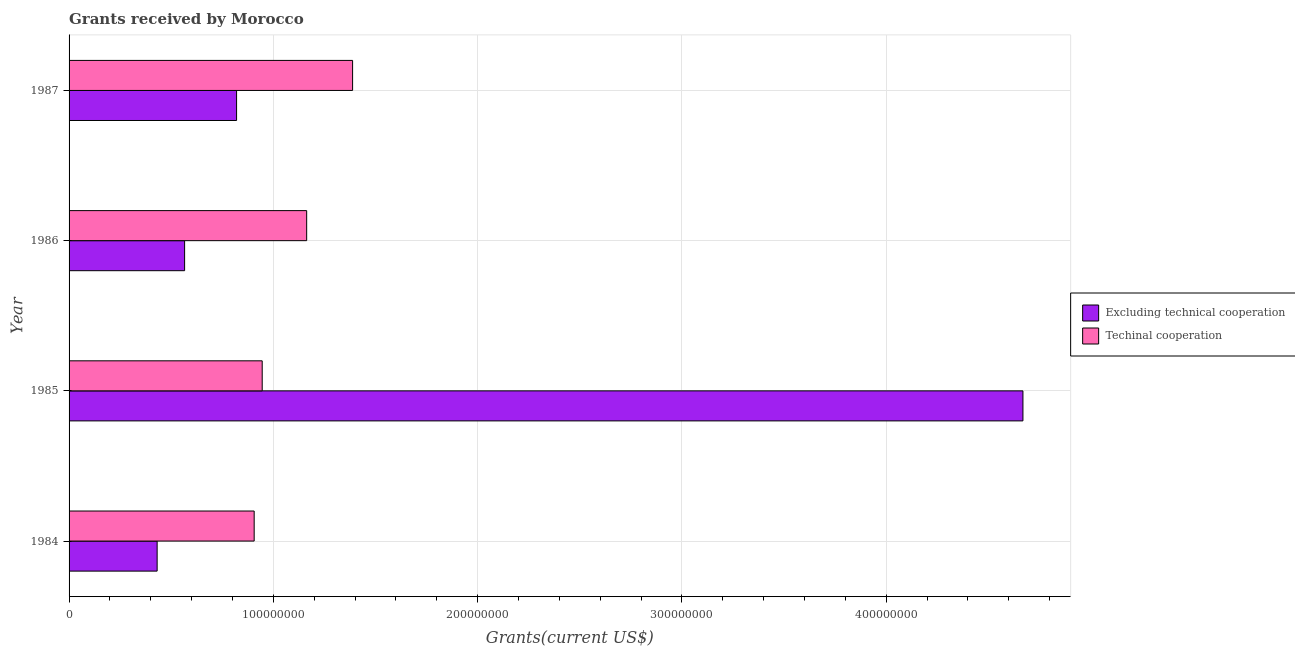Are the number of bars per tick equal to the number of legend labels?
Your answer should be very brief. Yes. How many bars are there on the 2nd tick from the bottom?
Your response must be concise. 2. What is the amount of grants received(excluding technical cooperation) in 1987?
Your response must be concise. 8.20e+07. Across all years, what is the maximum amount of grants received(excluding technical cooperation)?
Keep it short and to the point. 4.67e+08. Across all years, what is the minimum amount of grants received(excluding technical cooperation)?
Provide a short and direct response. 4.31e+07. In which year was the amount of grants received(excluding technical cooperation) maximum?
Keep it short and to the point. 1985. In which year was the amount of grants received(excluding technical cooperation) minimum?
Your answer should be very brief. 1984. What is the total amount of grants received(including technical cooperation) in the graph?
Give a very brief answer. 4.40e+08. What is the difference between the amount of grants received(excluding technical cooperation) in 1986 and that in 1987?
Offer a very short reply. -2.54e+07. What is the difference between the amount of grants received(including technical cooperation) in 1987 and the amount of grants received(excluding technical cooperation) in 1984?
Offer a terse response. 9.57e+07. What is the average amount of grants received(excluding technical cooperation) per year?
Your response must be concise. 1.62e+08. In the year 1985, what is the difference between the amount of grants received(excluding technical cooperation) and amount of grants received(including technical cooperation)?
Provide a succinct answer. 3.72e+08. What is the ratio of the amount of grants received(excluding technical cooperation) in 1985 to that in 1986?
Offer a very short reply. 8.26. Is the difference between the amount of grants received(excluding technical cooperation) in 1985 and 1987 greater than the difference between the amount of grants received(including technical cooperation) in 1985 and 1987?
Your answer should be very brief. Yes. What is the difference between the highest and the second highest amount of grants received(excluding technical cooperation)?
Keep it short and to the point. 3.85e+08. What is the difference between the highest and the lowest amount of grants received(excluding technical cooperation)?
Your answer should be compact. 4.24e+08. In how many years, is the amount of grants received(excluding technical cooperation) greater than the average amount of grants received(excluding technical cooperation) taken over all years?
Offer a terse response. 1. Is the sum of the amount of grants received(excluding technical cooperation) in 1985 and 1986 greater than the maximum amount of grants received(including technical cooperation) across all years?
Provide a short and direct response. Yes. What does the 1st bar from the top in 1984 represents?
Keep it short and to the point. Techinal cooperation. What does the 2nd bar from the bottom in 1986 represents?
Provide a short and direct response. Techinal cooperation. What is the difference between two consecutive major ticks on the X-axis?
Offer a very short reply. 1.00e+08. Are the values on the major ticks of X-axis written in scientific E-notation?
Make the answer very short. No. Does the graph contain any zero values?
Make the answer very short. No. Where does the legend appear in the graph?
Offer a very short reply. Center right. How are the legend labels stacked?
Make the answer very short. Vertical. What is the title of the graph?
Offer a very short reply. Grants received by Morocco. What is the label or title of the X-axis?
Provide a short and direct response. Grants(current US$). What is the Grants(current US$) of Excluding technical cooperation in 1984?
Your response must be concise. 4.31e+07. What is the Grants(current US$) in Techinal cooperation in 1984?
Your answer should be compact. 9.06e+07. What is the Grants(current US$) in Excluding technical cooperation in 1985?
Your answer should be compact. 4.67e+08. What is the Grants(current US$) of Techinal cooperation in 1985?
Provide a succinct answer. 9.45e+07. What is the Grants(current US$) of Excluding technical cooperation in 1986?
Your answer should be compact. 5.66e+07. What is the Grants(current US$) in Techinal cooperation in 1986?
Offer a very short reply. 1.16e+08. What is the Grants(current US$) of Excluding technical cooperation in 1987?
Provide a short and direct response. 8.20e+07. What is the Grants(current US$) of Techinal cooperation in 1987?
Keep it short and to the point. 1.39e+08. Across all years, what is the maximum Grants(current US$) in Excluding technical cooperation?
Provide a succinct answer. 4.67e+08. Across all years, what is the maximum Grants(current US$) of Techinal cooperation?
Provide a succinct answer. 1.39e+08. Across all years, what is the minimum Grants(current US$) of Excluding technical cooperation?
Offer a very short reply. 4.31e+07. Across all years, what is the minimum Grants(current US$) in Techinal cooperation?
Provide a succinct answer. 9.06e+07. What is the total Grants(current US$) of Excluding technical cooperation in the graph?
Your response must be concise. 6.49e+08. What is the total Grants(current US$) of Techinal cooperation in the graph?
Make the answer very short. 4.40e+08. What is the difference between the Grants(current US$) of Excluding technical cooperation in 1984 and that in 1985?
Keep it short and to the point. -4.24e+08. What is the difference between the Grants(current US$) in Techinal cooperation in 1984 and that in 1985?
Provide a short and direct response. -3.93e+06. What is the difference between the Grants(current US$) of Excluding technical cooperation in 1984 and that in 1986?
Ensure brevity in your answer.  -1.34e+07. What is the difference between the Grants(current US$) of Techinal cooperation in 1984 and that in 1986?
Your response must be concise. -2.57e+07. What is the difference between the Grants(current US$) of Excluding technical cooperation in 1984 and that in 1987?
Make the answer very short. -3.89e+07. What is the difference between the Grants(current US$) in Techinal cooperation in 1984 and that in 1987?
Your answer should be very brief. -4.82e+07. What is the difference between the Grants(current US$) of Excluding technical cooperation in 1985 and that in 1986?
Offer a very short reply. 4.10e+08. What is the difference between the Grants(current US$) in Techinal cooperation in 1985 and that in 1986?
Your answer should be compact. -2.18e+07. What is the difference between the Grants(current US$) in Excluding technical cooperation in 1985 and that in 1987?
Ensure brevity in your answer.  3.85e+08. What is the difference between the Grants(current US$) in Techinal cooperation in 1985 and that in 1987?
Your response must be concise. -4.42e+07. What is the difference between the Grants(current US$) of Excluding technical cooperation in 1986 and that in 1987?
Give a very brief answer. -2.54e+07. What is the difference between the Grants(current US$) in Techinal cooperation in 1986 and that in 1987?
Offer a very short reply. -2.25e+07. What is the difference between the Grants(current US$) in Excluding technical cooperation in 1984 and the Grants(current US$) in Techinal cooperation in 1985?
Your answer should be very brief. -5.14e+07. What is the difference between the Grants(current US$) in Excluding technical cooperation in 1984 and the Grants(current US$) in Techinal cooperation in 1986?
Provide a short and direct response. -7.32e+07. What is the difference between the Grants(current US$) in Excluding technical cooperation in 1984 and the Grants(current US$) in Techinal cooperation in 1987?
Make the answer very short. -9.57e+07. What is the difference between the Grants(current US$) of Excluding technical cooperation in 1985 and the Grants(current US$) of Techinal cooperation in 1986?
Provide a succinct answer. 3.51e+08. What is the difference between the Grants(current US$) in Excluding technical cooperation in 1985 and the Grants(current US$) in Techinal cooperation in 1987?
Keep it short and to the point. 3.28e+08. What is the difference between the Grants(current US$) in Excluding technical cooperation in 1986 and the Grants(current US$) in Techinal cooperation in 1987?
Provide a short and direct response. -8.22e+07. What is the average Grants(current US$) in Excluding technical cooperation per year?
Provide a succinct answer. 1.62e+08. What is the average Grants(current US$) in Techinal cooperation per year?
Give a very brief answer. 1.10e+08. In the year 1984, what is the difference between the Grants(current US$) in Excluding technical cooperation and Grants(current US$) in Techinal cooperation?
Make the answer very short. -4.75e+07. In the year 1985, what is the difference between the Grants(current US$) in Excluding technical cooperation and Grants(current US$) in Techinal cooperation?
Ensure brevity in your answer.  3.72e+08. In the year 1986, what is the difference between the Grants(current US$) in Excluding technical cooperation and Grants(current US$) in Techinal cooperation?
Provide a short and direct response. -5.98e+07. In the year 1987, what is the difference between the Grants(current US$) of Excluding technical cooperation and Grants(current US$) of Techinal cooperation?
Your response must be concise. -5.68e+07. What is the ratio of the Grants(current US$) of Excluding technical cooperation in 1984 to that in 1985?
Offer a terse response. 0.09. What is the ratio of the Grants(current US$) in Techinal cooperation in 1984 to that in 1985?
Give a very brief answer. 0.96. What is the ratio of the Grants(current US$) in Excluding technical cooperation in 1984 to that in 1986?
Your response must be concise. 0.76. What is the ratio of the Grants(current US$) of Techinal cooperation in 1984 to that in 1986?
Ensure brevity in your answer.  0.78. What is the ratio of the Grants(current US$) in Excluding technical cooperation in 1984 to that in 1987?
Your response must be concise. 0.53. What is the ratio of the Grants(current US$) of Techinal cooperation in 1984 to that in 1987?
Make the answer very short. 0.65. What is the ratio of the Grants(current US$) in Excluding technical cooperation in 1985 to that in 1986?
Ensure brevity in your answer.  8.26. What is the ratio of the Grants(current US$) of Techinal cooperation in 1985 to that in 1986?
Provide a short and direct response. 0.81. What is the ratio of the Grants(current US$) in Excluding technical cooperation in 1985 to that in 1987?
Provide a succinct answer. 5.69. What is the ratio of the Grants(current US$) in Techinal cooperation in 1985 to that in 1987?
Keep it short and to the point. 0.68. What is the ratio of the Grants(current US$) in Excluding technical cooperation in 1986 to that in 1987?
Make the answer very short. 0.69. What is the ratio of the Grants(current US$) in Techinal cooperation in 1986 to that in 1987?
Offer a very short reply. 0.84. What is the difference between the highest and the second highest Grants(current US$) in Excluding technical cooperation?
Provide a succinct answer. 3.85e+08. What is the difference between the highest and the second highest Grants(current US$) of Techinal cooperation?
Ensure brevity in your answer.  2.25e+07. What is the difference between the highest and the lowest Grants(current US$) of Excluding technical cooperation?
Ensure brevity in your answer.  4.24e+08. What is the difference between the highest and the lowest Grants(current US$) in Techinal cooperation?
Provide a succinct answer. 4.82e+07. 